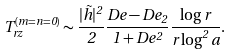Convert formula to latex. <formula><loc_0><loc_0><loc_500><loc_500>T _ { r z } ^ { ( m = n = 0 ) } \sim \frac { | { \tilde { h } } | ^ { 2 } } { 2 } \frac { D e - D e _ { 2 } } { 1 + D e ^ { 2 } } \frac { \log r } { r \log ^ { 2 } a } .</formula> 